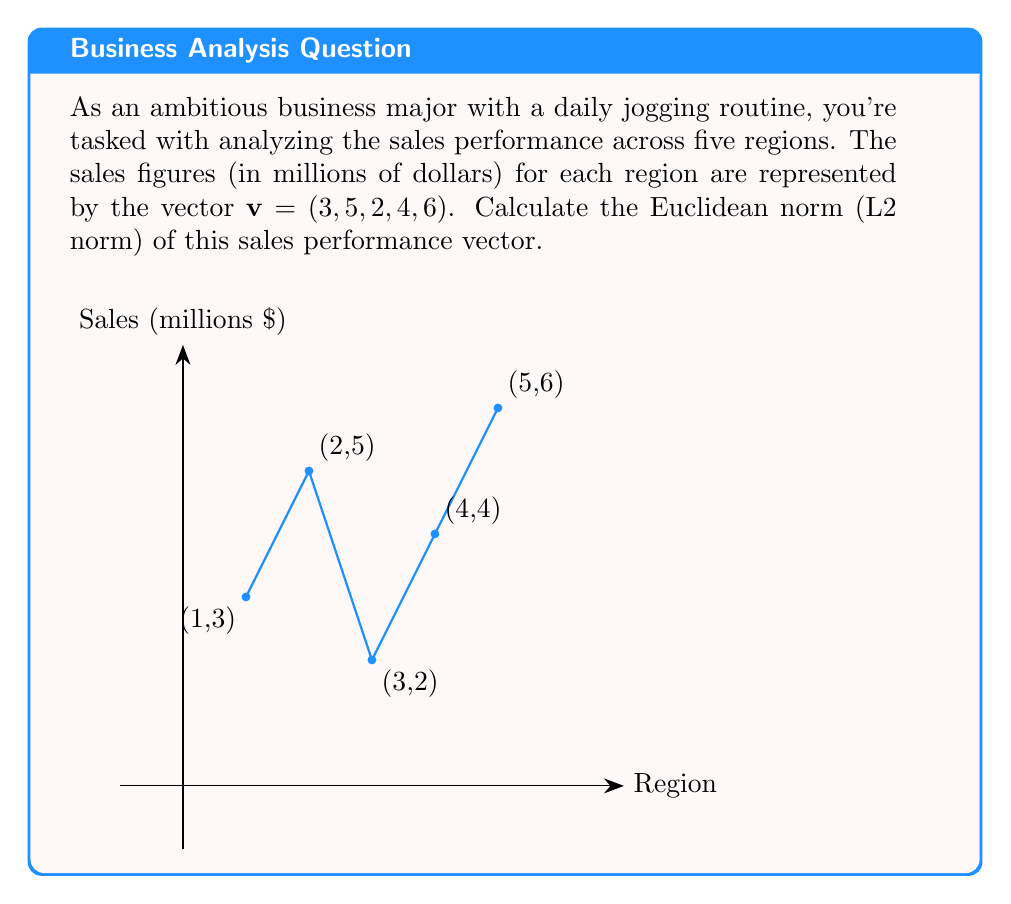Solve this math problem. To calculate the Euclidean norm (L2 norm) of the sales performance vector, we'll follow these steps:

1) The Euclidean norm of a vector $\mathbf{v} = (v_1, v_2, ..., v_n)$ is defined as:

   $$\|\mathbf{v}\|_2 = \sqrt{\sum_{i=1}^n |v_i|^2}$$

2) For our vector $\mathbf{v} = (3, 5, 2, 4, 6)$, we need to square each component and sum them:

   $$\|\mathbf{v}\|_2 = \sqrt{3^2 + 5^2 + 2^2 + 4^2 + 6^2}$$

3) Let's calculate each term:
   
   $$\|\mathbf{v}\|_2 = \sqrt{9 + 25 + 4 + 16 + 36}$$

4) Sum the values under the square root:

   $$\|\mathbf{v}\|_2 = \sqrt{90}$$

5) Simplify the square root:

   $$\|\mathbf{v}\|_2 = 3\sqrt{10}$$

This result, $3\sqrt{10}$, represents the Euclidean norm of the sales performance vector. It gives a measure of the overall magnitude of sales across all regions, taking into account the contributions from each region in a way that larger values have a more significant impact on the final result.
Answer: $3\sqrt{10}$ 